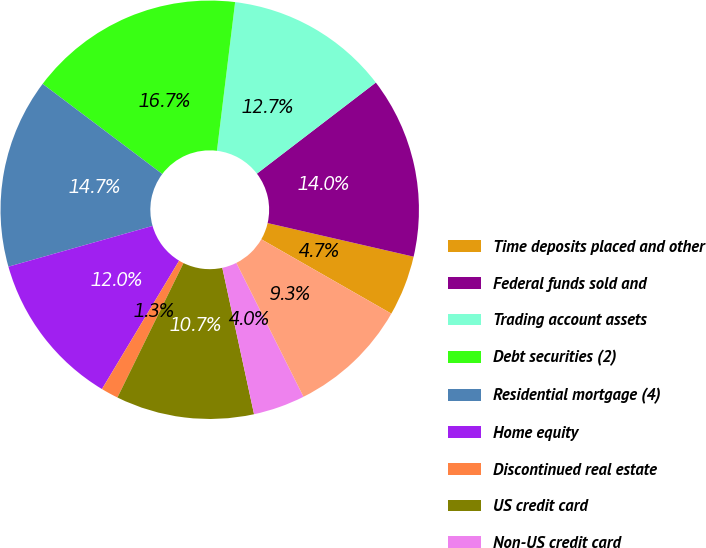<chart> <loc_0><loc_0><loc_500><loc_500><pie_chart><fcel>Time deposits placed and other<fcel>Federal funds sold and<fcel>Trading account assets<fcel>Debt securities (2)<fcel>Residential mortgage (4)<fcel>Home equity<fcel>Discontinued real estate<fcel>US credit card<fcel>Non-US credit card<fcel>Direct/Indirect consumer (5)<nl><fcel>4.67%<fcel>14.0%<fcel>12.66%<fcel>16.66%<fcel>14.66%<fcel>12.0%<fcel>1.34%<fcel>10.67%<fcel>4.0%<fcel>9.33%<nl></chart> 